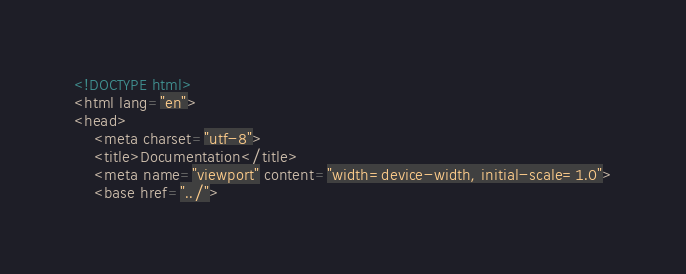<code> <loc_0><loc_0><loc_500><loc_500><_HTML_><!DOCTYPE html>
<html lang="en">
<head>
    <meta charset="utf-8">
    <title>Documentation</title>
    <meta name="viewport" content="width=device-width, initial-scale=1.0">
    <base href="../"></code> 